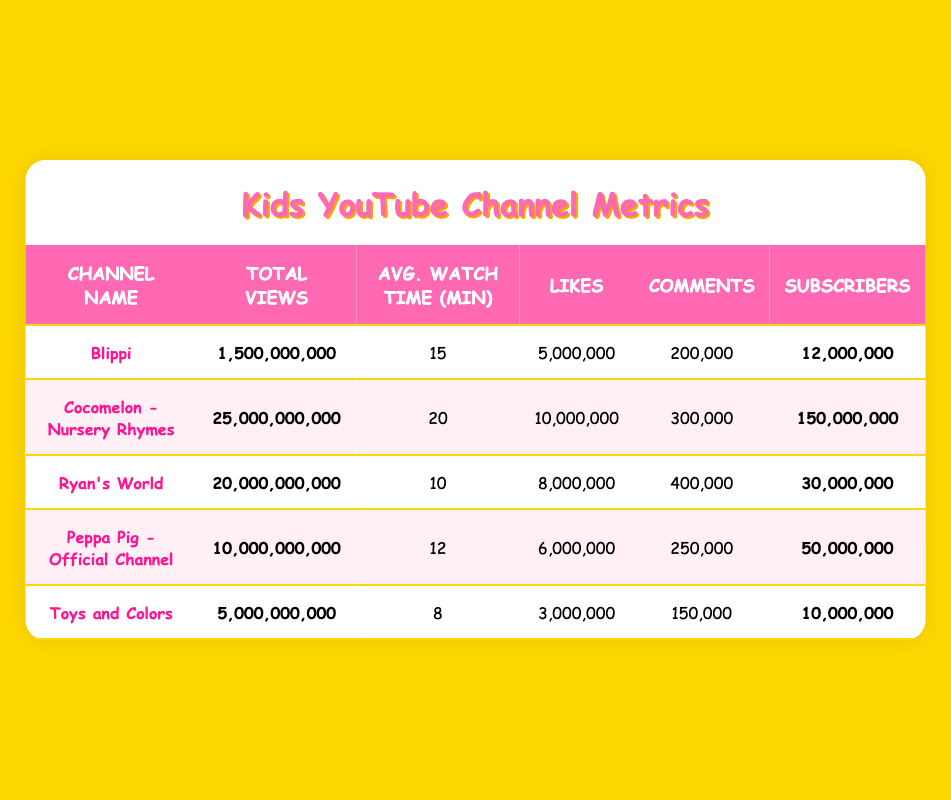What is the channel with the highest number of subscribers? By scanning through the Subscriber column in the table, Cocomelon - Nursery Rhymes has the highest number with 150,000,000.
Answer: Cocomelon - Nursery Rhymes Which channel has the shortest average watch time? Looking at the Avg. Watch Time column, Toys and Colors has the shortest average watch time of 8 minutes.
Answer: Toys and Colors How many total views do Ryan's World and Peppa Pig - Official Channel combined have? To find the total views for both channels, add Ryan's World (20,000,000,000) and Peppa Pig (10,000,000,000): 20,000,000,000 + 10,000,000,000 = 30,000,000,000.
Answer: 30,000,000,000 Is the average watch time for Cocomelon - Nursery Rhymes greater than 18 minutes? Cocomelon's average watch time is 20 minutes, which is indeed greater than 18.
Answer: Yes What is the total number of likes across all five channels? Summing the Likes column values: 5,000,000 + 10,000,000 + 8,000,000 + 6,000,000 + 3,000,000 = 32,000,000.
Answer: 32,000,000 Which channel has the most comments? Checking the Comments column, Ryan's World has the most comments with 400,000.
Answer: Ryan's World What is the average number of views per subscriber for Blippi? To compute this, divide Blippi's total views (1,500,000,000) by the number of subscribers (12,000,000): 1,500,000,000 / 12,000,000 = 125.
Answer: 125 Are the total views for Peppa Pig - Official Channel and Toys and Colors less than 15 billion? Peppa Pig has 10,000,000,000 views and Toys and Colors has 5,000,000,000 views, which combine to 15,000,000,000. Thus, they are not less than 15 billion.
Answer: No Which channel ranks second in total views? By referencing the Total Views column, Ryan's World has 20,000,000,000 views, making it the second highest after Cocomelon.
Answer: Ryan's World 